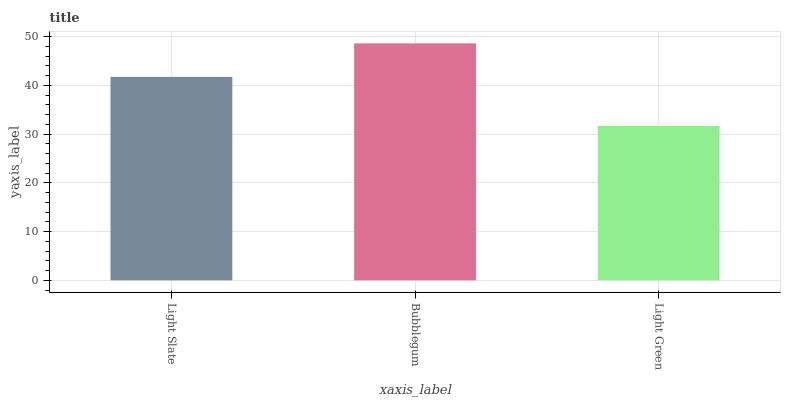Is Light Green the minimum?
Answer yes or no. Yes. Is Bubblegum the maximum?
Answer yes or no. Yes. Is Bubblegum the minimum?
Answer yes or no. No. Is Light Green the maximum?
Answer yes or no. No. Is Bubblegum greater than Light Green?
Answer yes or no. Yes. Is Light Green less than Bubblegum?
Answer yes or no. Yes. Is Light Green greater than Bubblegum?
Answer yes or no. No. Is Bubblegum less than Light Green?
Answer yes or no. No. Is Light Slate the high median?
Answer yes or no. Yes. Is Light Slate the low median?
Answer yes or no. Yes. Is Bubblegum the high median?
Answer yes or no. No. Is Light Green the low median?
Answer yes or no. No. 